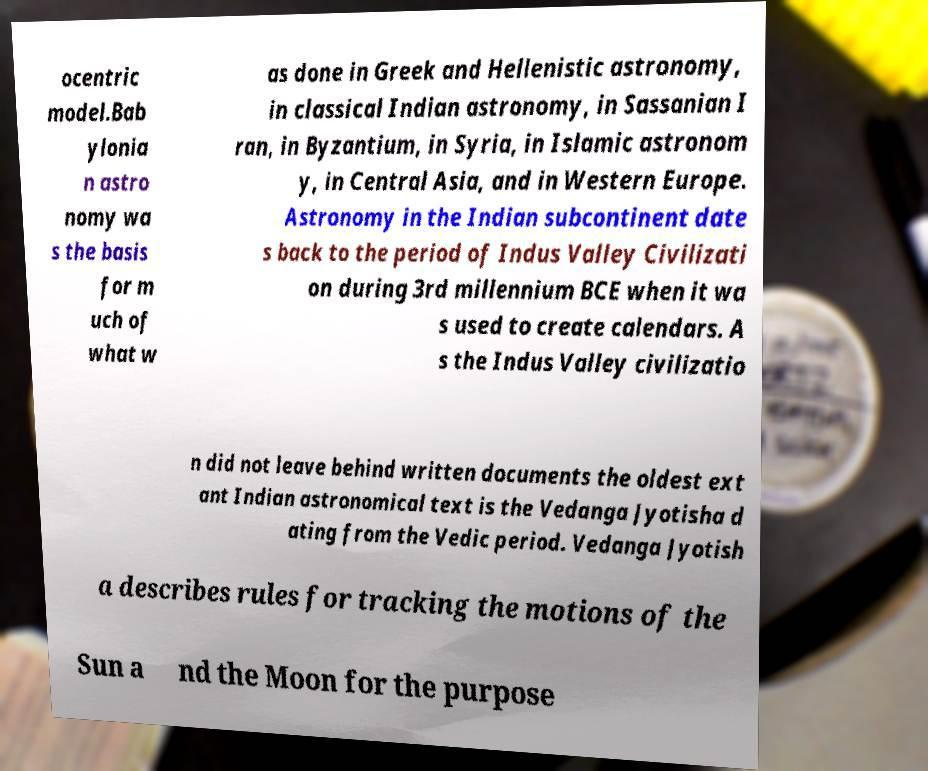Please identify and transcribe the text found in this image. ocentric model.Bab ylonia n astro nomy wa s the basis for m uch of what w as done in Greek and Hellenistic astronomy, in classical Indian astronomy, in Sassanian I ran, in Byzantium, in Syria, in Islamic astronom y, in Central Asia, and in Western Europe. Astronomy in the Indian subcontinent date s back to the period of Indus Valley Civilizati on during 3rd millennium BCE when it wa s used to create calendars. A s the Indus Valley civilizatio n did not leave behind written documents the oldest ext ant Indian astronomical text is the Vedanga Jyotisha d ating from the Vedic period. Vedanga Jyotish a describes rules for tracking the motions of the Sun a nd the Moon for the purpose 